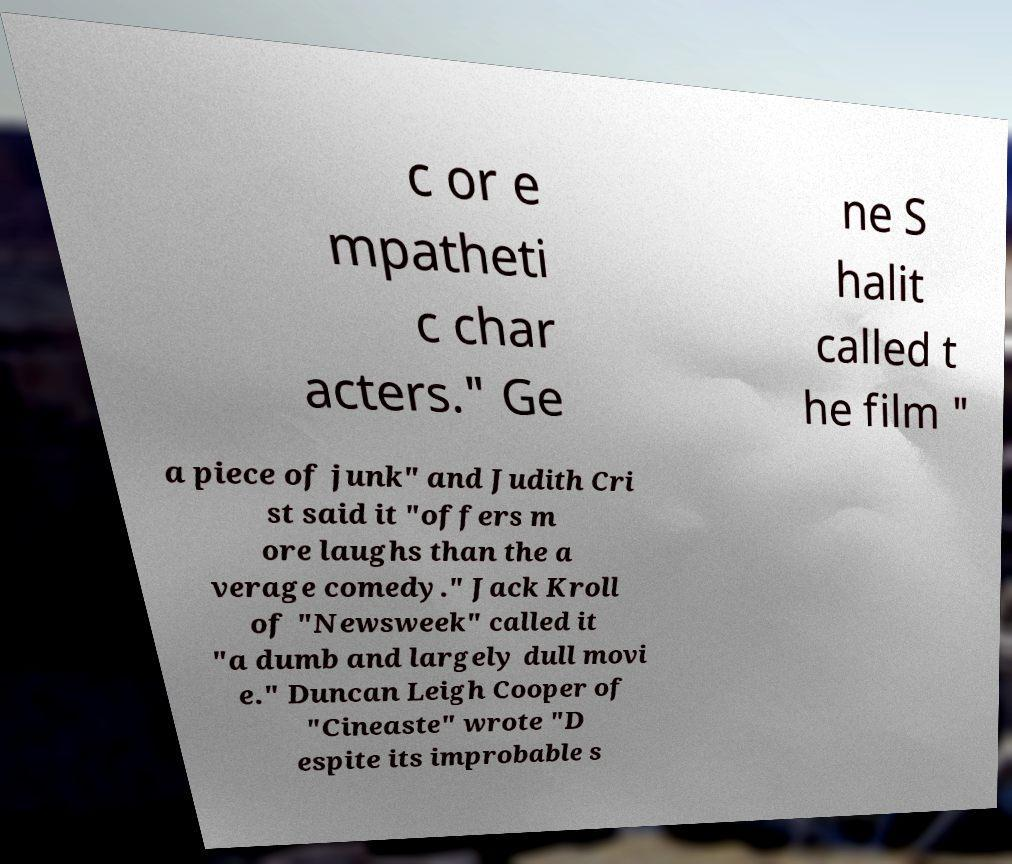Please read and relay the text visible in this image. What does it say? c or e mpatheti c char acters." Ge ne S halit called t he film " a piece of junk" and Judith Cri st said it "offers m ore laughs than the a verage comedy." Jack Kroll of "Newsweek" called it "a dumb and largely dull movi e." Duncan Leigh Cooper of "Cineaste" wrote "D espite its improbable s 